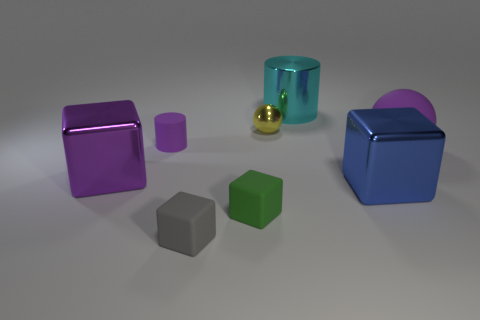What texture appears to be on the purple cube? The texture on the purple cube resembles a glossy metallic finish, giving it a reflective sheen that stands out from the other objects. 